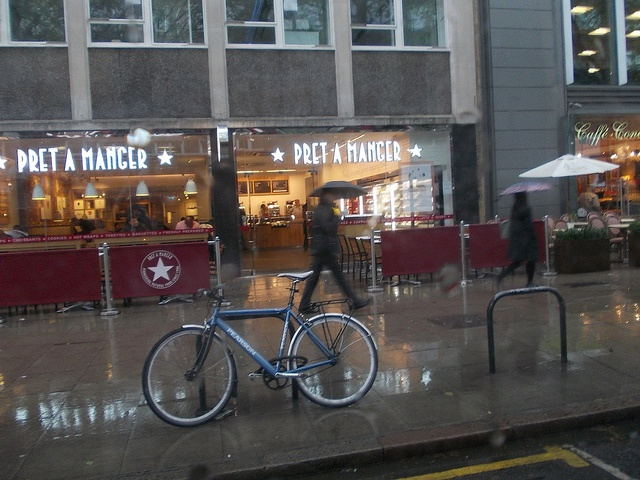Describe the objects in this image and their specific colors. I can see bicycle in darkgray, gray, black, and navy tones, people in darkgray, black, and gray tones, people in darkgray and black tones, umbrella in darkgray, lightgray, gray, and black tones, and umbrella in darkgray, gray, and black tones in this image. 